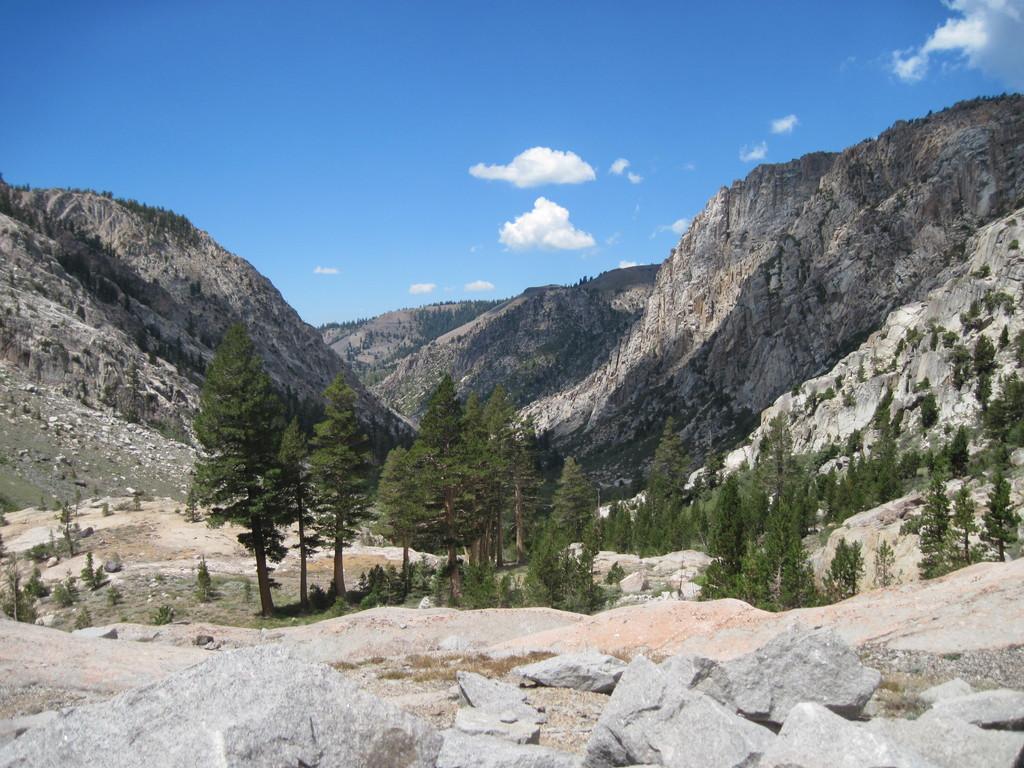How would you summarize this image in a sentence or two? Here we can see stones on the ground. In the background there are trees,mountains and clouds in the sky. 